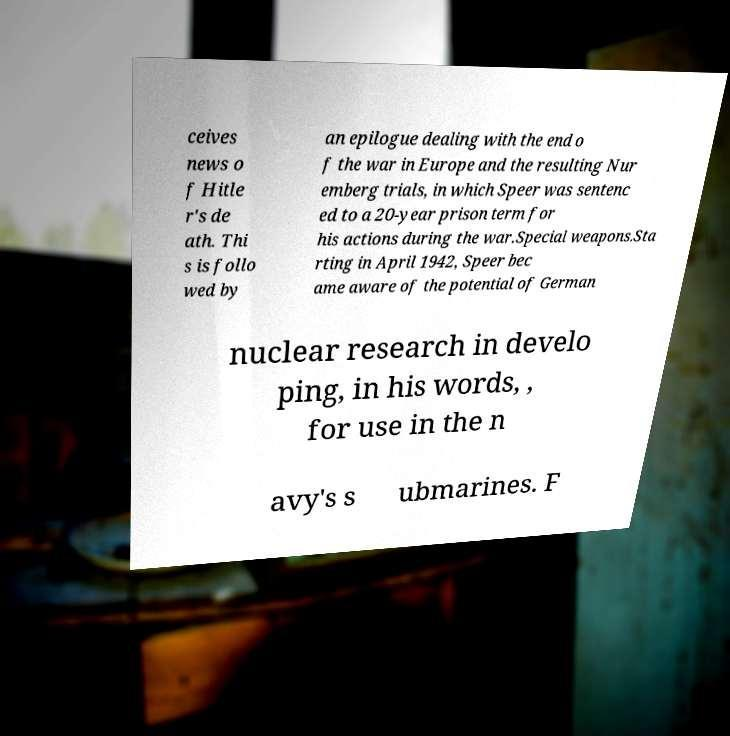Can you read and provide the text displayed in the image?This photo seems to have some interesting text. Can you extract and type it out for me? ceives news o f Hitle r's de ath. Thi s is follo wed by an epilogue dealing with the end o f the war in Europe and the resulting Nur emberg trials, in which Speer was sentenc ed to a 20-year prison term for his actions during the war.Special weapons.Sta rting in April 1942, Speer bec ame aware of the potential of German nuclear research in develo ping, in his words, , for use in the n avy's s ubmarines. F 